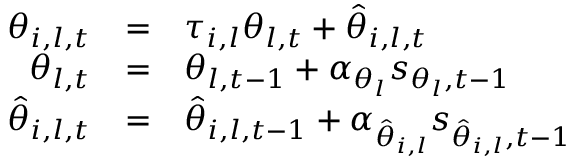Convert formula to latex. <formula><loc_0><loc_0><loc_500><loc_500>\begin{array} { r c l } { \theta _ { i , l , t } } & { = } & { \tau _ { i , l } \theta _ { l , t } + \hat { \theta } _ { i , l , t } } \\ { \theta _ { l , t } } & { = } & { \theta _ { l , t - 1 } + \alpha _ { \theta _ { l } } s _ { \theta _ { l } , t - 1 } } \\ { \hat { \theta } _ { i , l , t } } & { = } & { \hat { \theta } _ { i , l , t - 1 } + \alpha _ { \hat { \theta } _ { i , l } } s _ { \hat { \theta } _ { i , l } , t - 1 } } \end{array}</formula> 